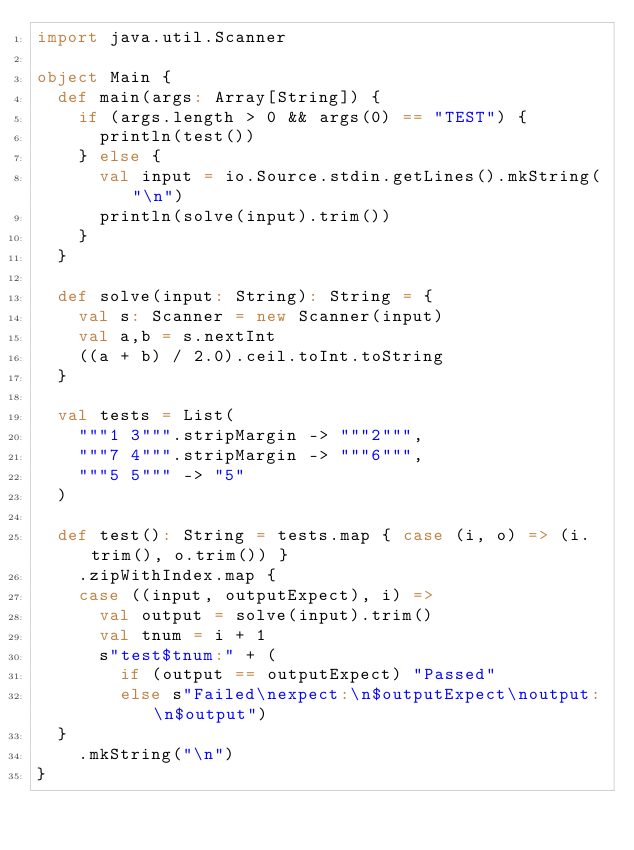<code> <loc_0><loc_0><loc_500><loc_500><_Scala_>import java.util.Scanner

object Main {
  def main(args: Array[String]) {
    if (args.length > 0 && args(0) == "TEST") {
      println(test())
    } else {
      val input = io.Source.stdin.getLines().mkString("\n")
      println(solve(input).trim())
    }
  }

  def solve(input: String): String = {
    val s: Scanner = new Scanner(input)
    val a,b = s.nextInt
    ((a + b) / 2.0).ceil.toInt.toString
  }

  val tests = List(
    """1 3""".stripMargin -> """2""",
    """7 4""".stripMargin -> """6""",
    """5 5""" -> "5"
  )

  def test(): String = tests.map { case (i, o) => (i.trim(), o.trim()) }
    .zipWithIndex.map {
    case ((input, outputExpect), i) =>
      val output = solve(input).trim()
      val tnum = i + 1
      s"test$tnum:" + (
        if (output == outputExpect) "Passed"
        else s"Failed\nexpect:\n$outputExpect\noutput:\n$output")
  }
    .mkString("\n")
}</code> 